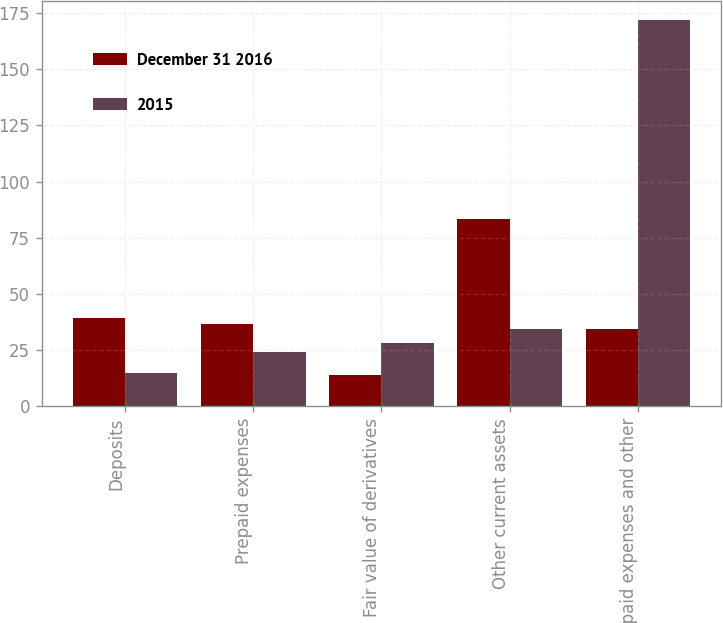<chart> <loc_0><loc_0><loc_500><loc_500><stacked_bar_chart><ecel><fcel>Deposits<fcel>Prepaid expenses<fcel>Fair value of derivatives<fcel>Other current assets<fcel>Prepaid expenses and other<nl><fcel>December 31 2016<fcel>39.4<fcel>36.5<fcel>14.1<fcel>83.5<fcel>34.4<nl><fcel>2015<fcel>14.8<fcel>24.1<fcel>28.1<fcel>34.4<fcel>171.8<nl></chart> 